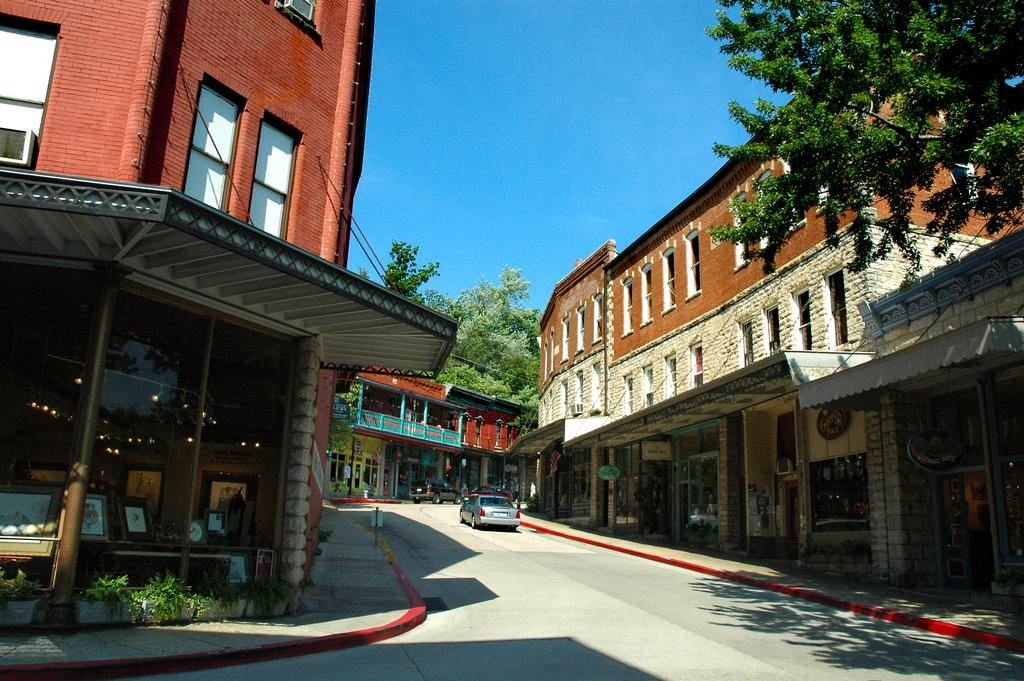What type of structures can be seen in the image? There are buildings in the image. What other elements are present in the image besides buildings? There are trees, vehicles, frames in a building on the left side of the image, and sign boards in the background of the image. What scientific experiments are being conducted in the image? There is no indication of any scientific experiments being conducted in the image. 